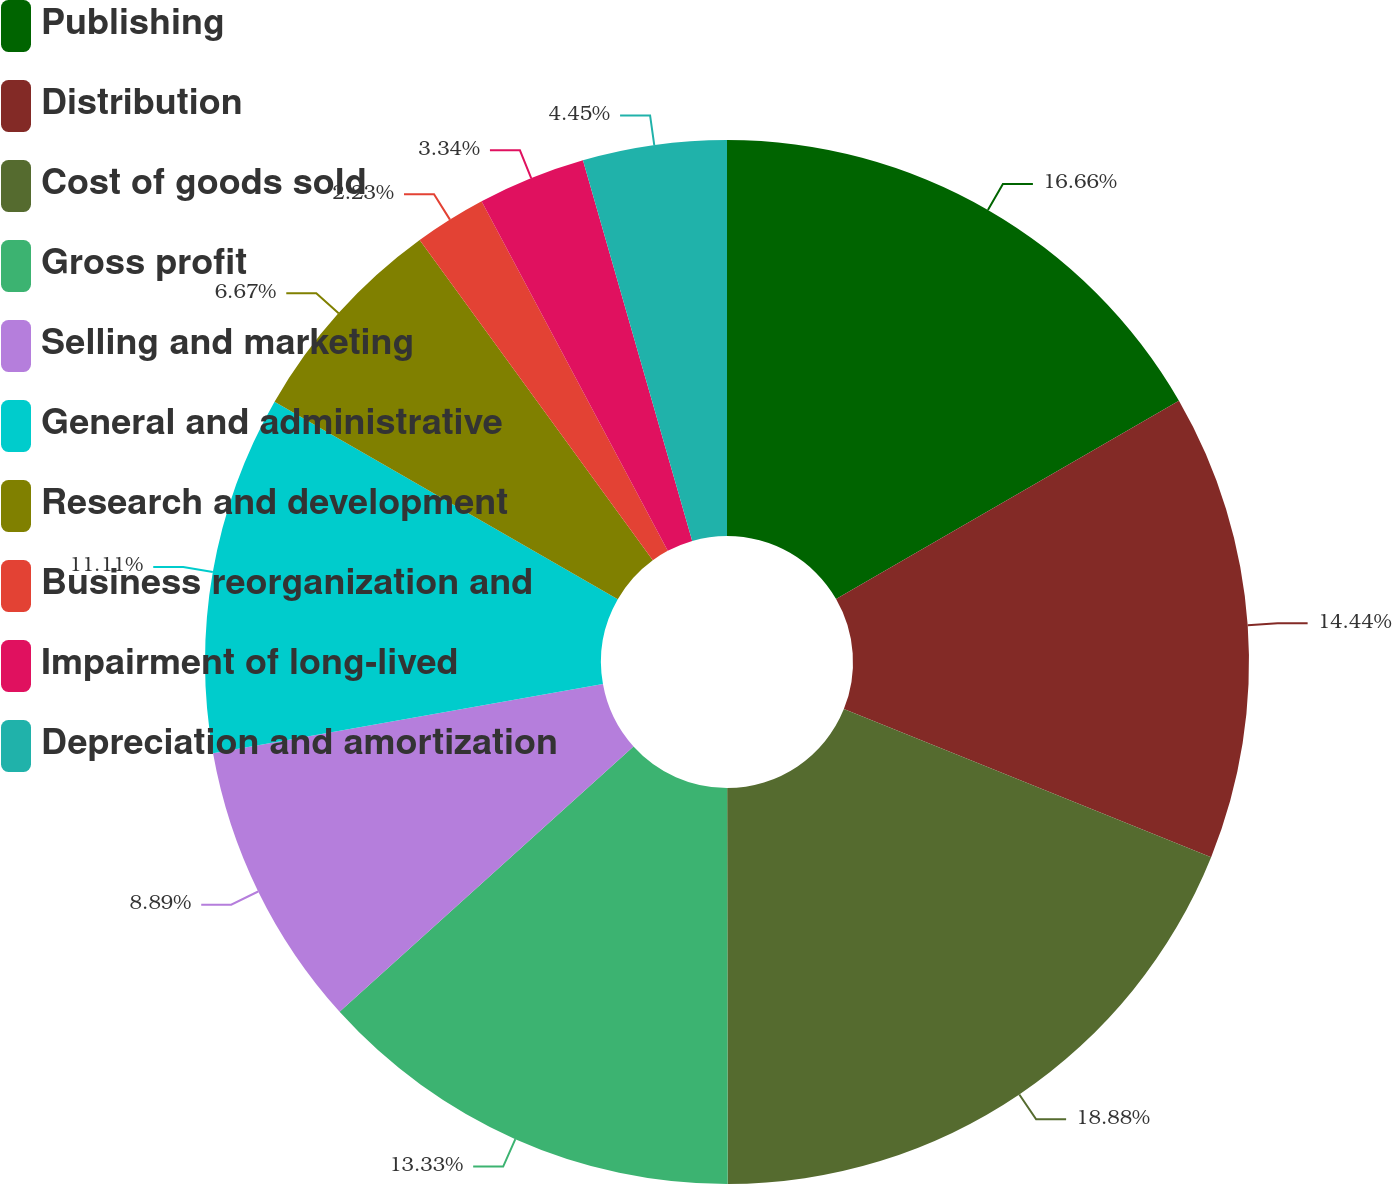Convert chart. <chart><loc_0><loc_0><loc_500><loc_500><pie_chart><fcel>Publishing<fcel>Distribution<fcel>Cost of goods sold<fcel>Gross profit<fcel>Selling and marketing<fcel>General and administrative<fcel>Research and development<fcel>Business reorganization and<fcel>Impairment of long-lived<fcel>Depreciation and amortization<nl><fcel>16.66%<fcel>14.44%<fcel>18.88%<fcel>13.33%<fcel>8.89%<fcel>11.11%<fcel>6.67%<fcel>2.23%<fcel>3.34%<fcel>4.45%<nl></chart> 